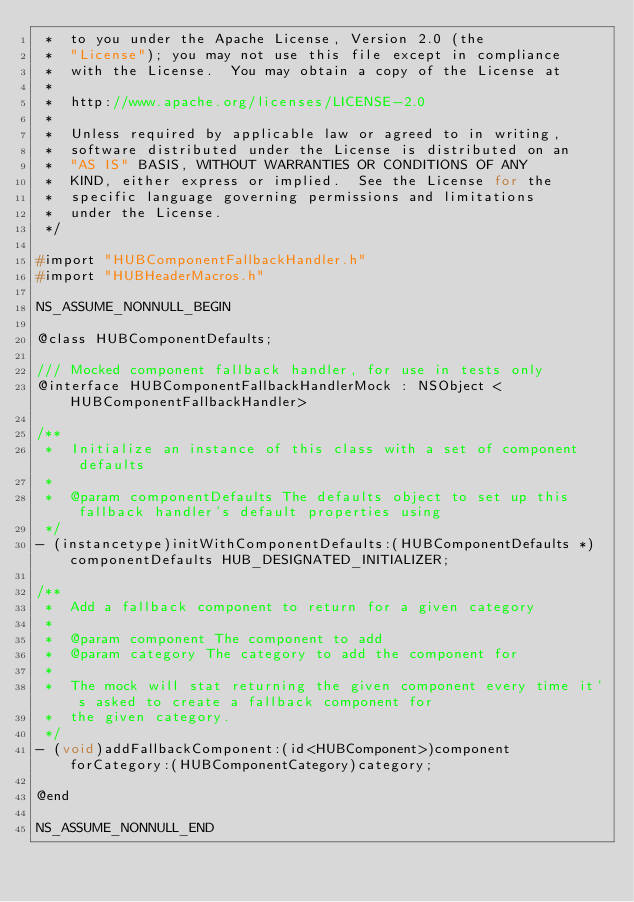Convert code to text. <code><loc_0><loc_0><loc_500><loc_500><_C_> *  to you under the Apache License, Version 2.0 (the
 *  "License"); you may not use this file except in compliance
 *  with the License.  You may obtain a copy of the License at
 *
 *  http://www.apache.org/licenses/LICENSE-2.0
 *
 *  Unless required by applicable law or agreed to in writing,
 *  software distributed under the License is distributed on an
 *  "AS IS" BASIS, WITHOUT WARRANTIES OR CONDITIONS OF ANY
 *  KIND, either express or implied.  See the License for the
 *  specific language governing permissions and limitations
 *  under the License.
 */

#import "HUBComponentFallbackHandler.h"
#import "HUBHeaderMacros.h"

NS_ASSUME_NONNULL_BEGIN

@class HUBComponentDefaults;

/// Mocked component fallback handler, for use in tests only
@interface HUBComponentFallbackHandlerMock : NSObject <HUBComponentFallbackHandler>

/**
 *  Initialize an instance of this class with a set of component defaults
 *
 *  @param componentDefaults The defaults object to set up this fallback handler's default properties using
 */
- (instancetype)initWithComponentDefaults:(HUBComponentDefaults *)componentDefaults HUB_DESIGNATED_INITIALIZER;

/**
 *  Add a fallback component to return for a given category
 *
 *  @param component The component to add
 *  @param category The category to add the component for
 *
 *  The mock will stat returning the given component every time it's asked to create a fallback component for
 *  the given category.
 */
- (void)addFallbackComponent:(id<HUBComponent>)component forCategory:(HUBComponentCategory)category;

@end

NS_ASSUME_NONNULL_END
</code> 